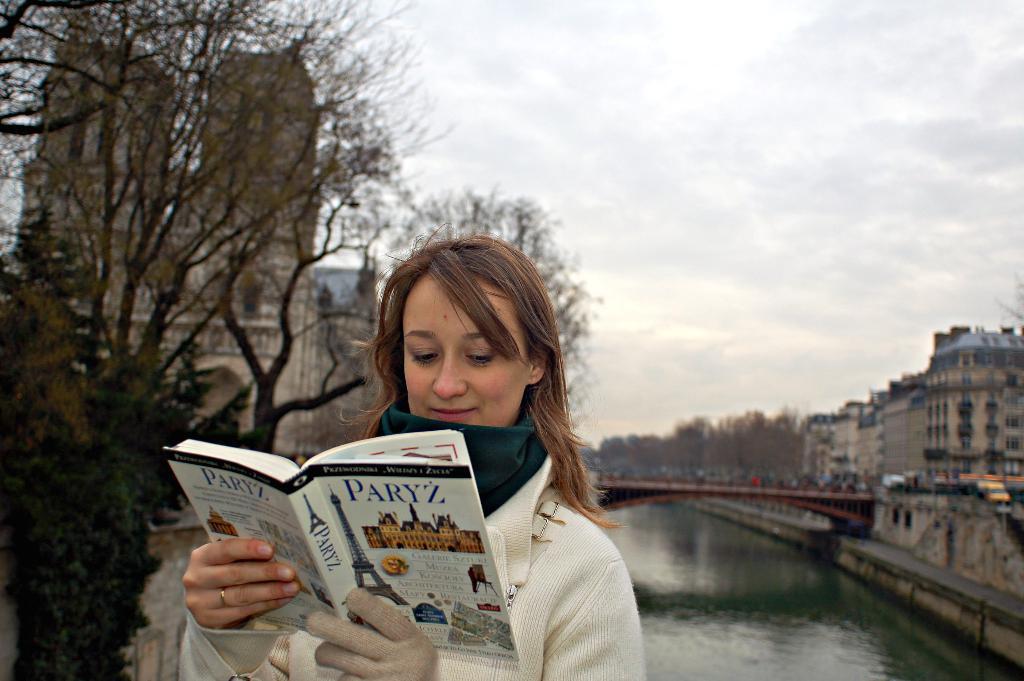How would you summarize this image in a sentence or two? This is an outside view. Here I can see a woman wearing white color jacket, holding a book in the hands and looking into the book. In the background there is a river and also I can see a bridge. On the right and left sides of the image I can see the buildings and trees. At the top of the image I can see the sky. 